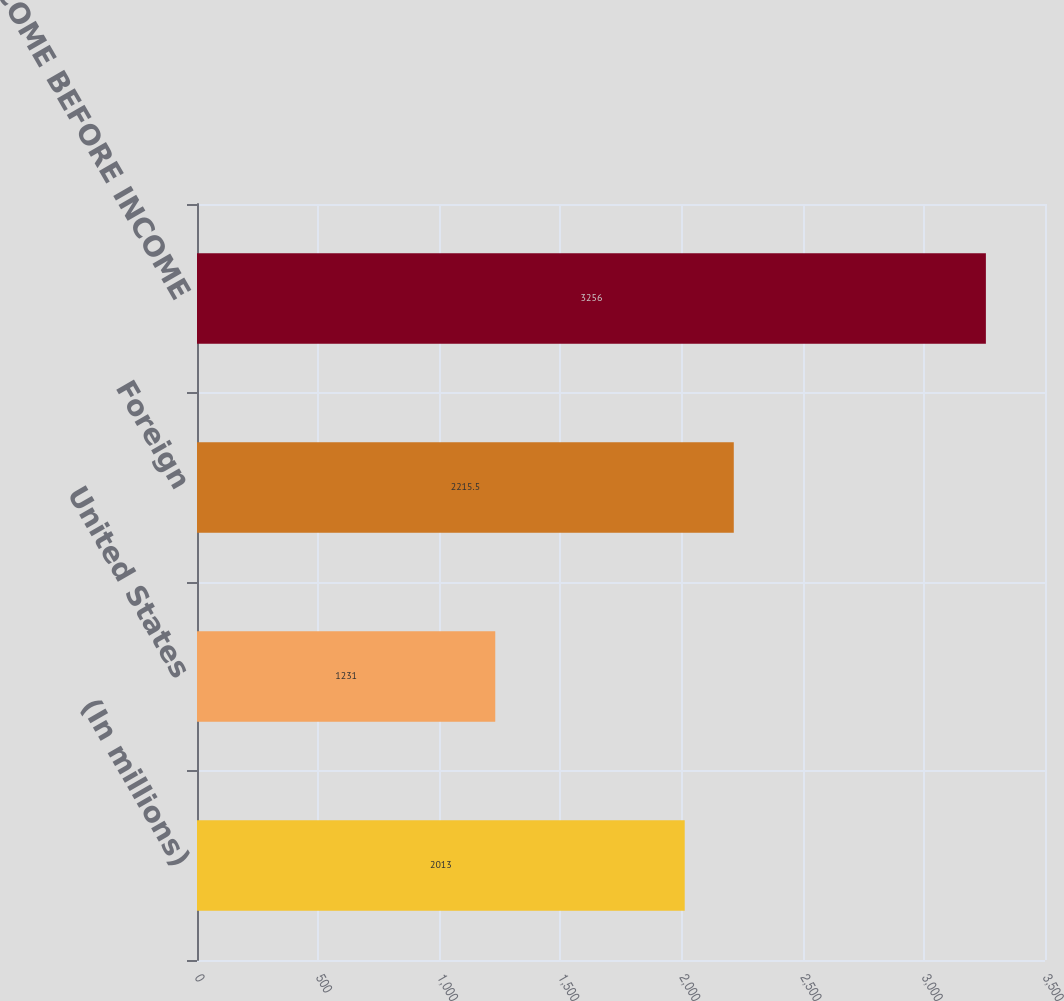Convert chart to OTSL. <chart><loc_0><loc_0><loc_500><loc_500><bar_chart><fcel>(In millions)<fcel>United States<fcel>Foreign<fcel>TOTAL INCOME BEFORE INCOME<nl><fcel>2013<fcel>1231<fcel>2215.5<fcel>3256<nl></chart> 